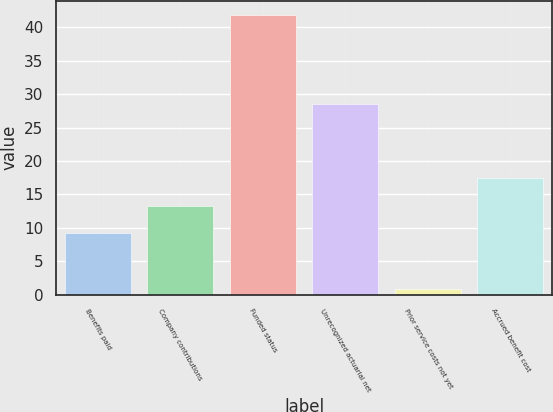Convert chart to OTSL. <chart><loc_0><loc_0><loc_500><loc_500><bar_chart><fcel>Benefits paid<fcel>Company contributions<fcel>Funded status<fcel>Unrecognized actuarial net<fcel>Prior service costs not yet<fcel>Accrued benefit cost<nl><fcel>9.2<fcel>13.31<fcel>41.9<fcel>28.6<fcel>0.8<fcel>17.42<nl></chart> 